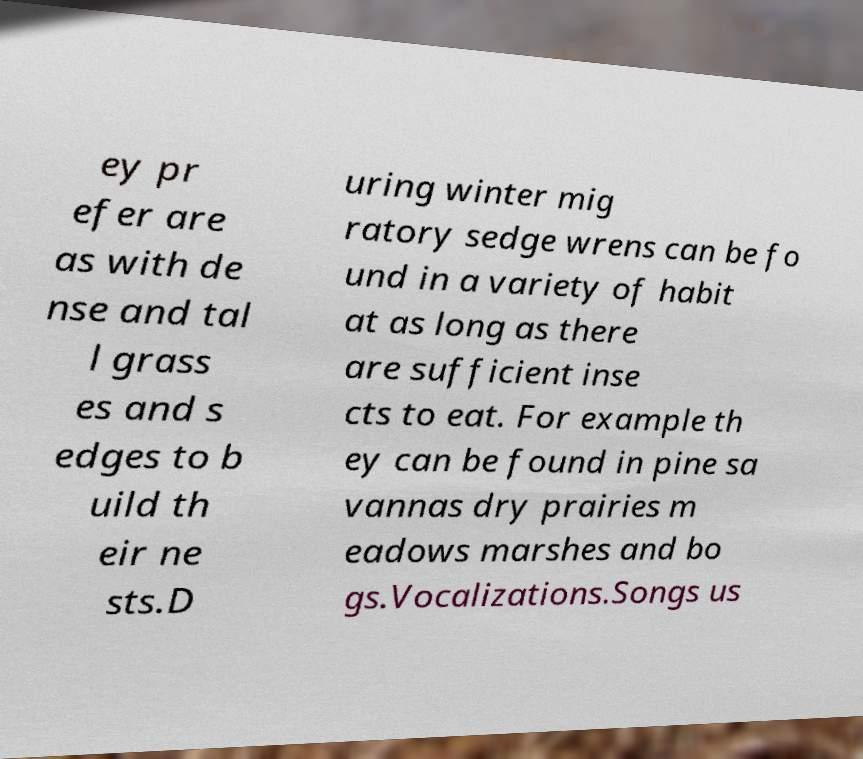Please read and relay the text visible in this image. What does it say? ey pr efer are as with de nse and tal l grass es and s edges to b uild th eir ne sts.D uring winter mig ratory sedge wrens can be fo und in a variety of habit at as long as there are sufficient inse cts to eat. For example th ey can be found in pine sa vannas dry prairies m eadows marshes and bo gs.Vocalizations.Songs us 